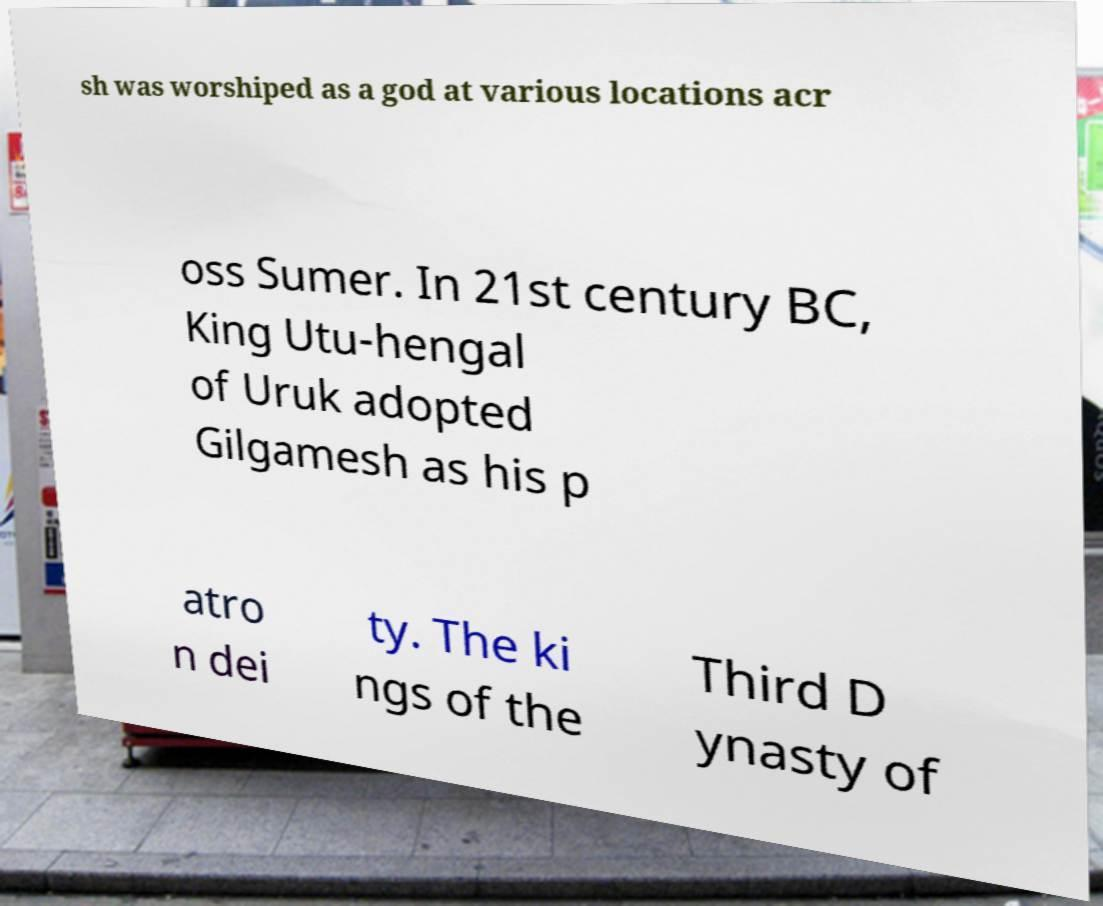Please identify and transcribe the text found in this image. sh was worshiped as a god at various locations acr oss Sumer. In 21st century BC, King Utu-hengal of Uruk adopted Gilgamesh as his p atro n dei ty. The ki ngs of the Third D ynasty of 